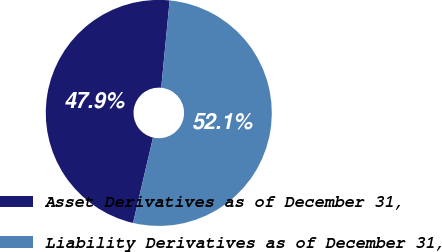Convert chart. <chart><loc_0><loc_0><loc_500><loc_500><pie_chart><fcel>Asset Derivatives as of December 31,<fcel>Liability Derivatives as of December 31,<nl><fcel>47.88%<fcel>52.12%<nl></chart> 